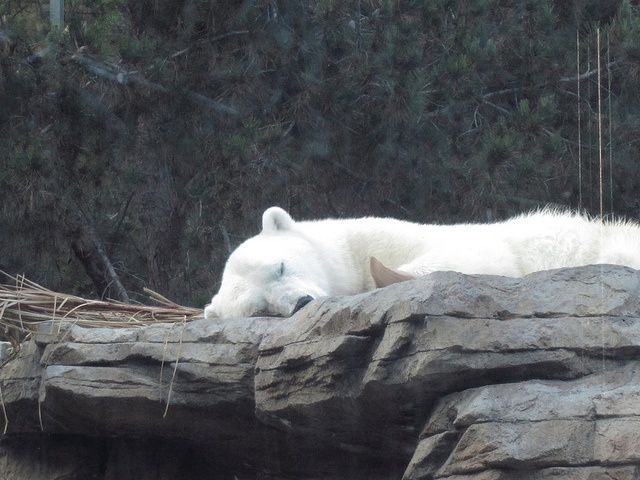Describe the objects in this image and their specific colors. I can see a bear in black, white, darkgray, gray, and lightgray tones in this image. 